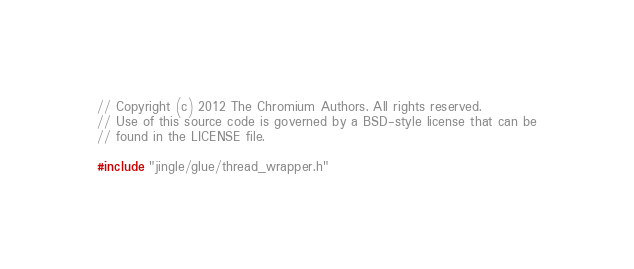<code> <loc_0><loc_0><loc_500><loc_500><_C++_>// Copyright (c) 2012 The Chromium Authors. All rights reserved.
// Use of this source code is governed by a BSD-style license that can be
// found in the LICENSE file.

#include "jingle/glue/thread_wrapper.h"
</code> 